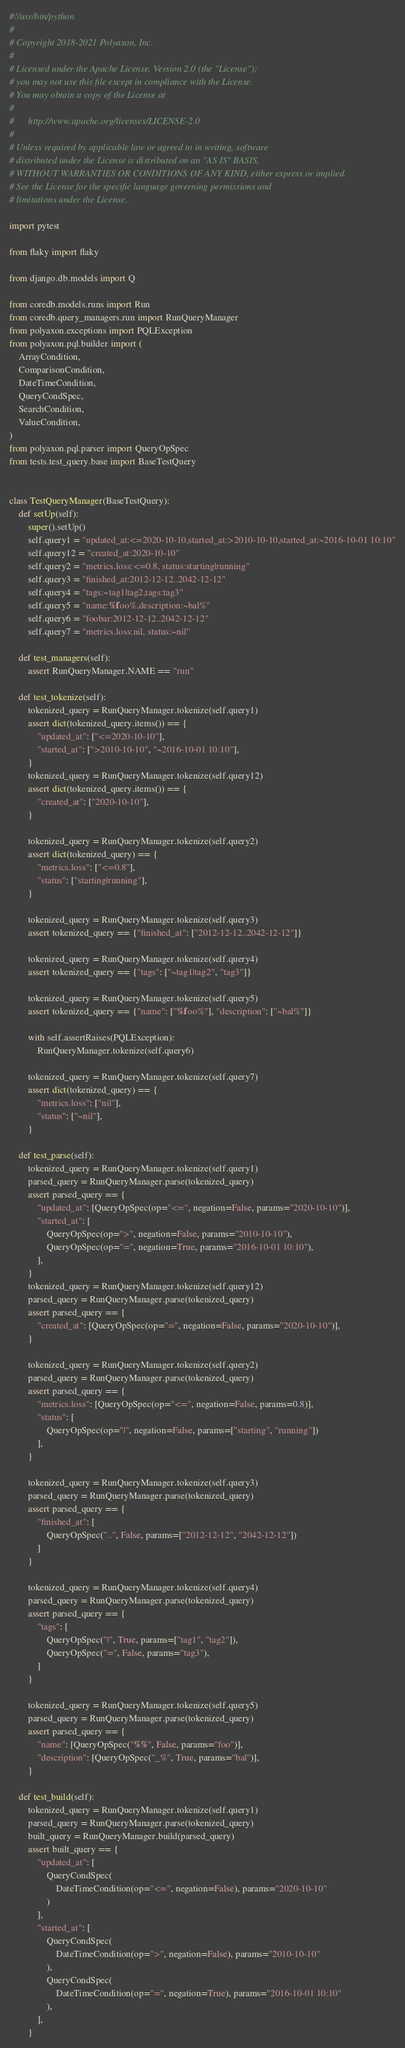Convert code to text. <code><loc_0><loc_0><loc_500><loc_500><_Python_>#!/usr/bin/python
#
# Copyright 2018-2021 Polyaxon, Inc.
#
# Licensed under the Apache License, Version 2.0 (the "License");
# you may not use this file except in compliance with the License.
# You may obtain a copy of the License at
#
#      http://www.apache.org/licenses/LICENSE-2.0
#
# Unless required by applicable law or agreed to in writing, software
# distributed under the License is distributed on an "AS IS" BASIS,
# WITHOUT WARRANTIES OR CONDITIONS OF ANY KIND, either express or implied.
# See the License for the specific language governing permissions and
# limitations under the License.

import pytest

from flaky import flaky

from django.db.models import Q

from coredb.models.runs import Run
from coredb.query_managers.run import RunQueryManager
from polyaxon.exceptions import PQLException
from polyaxon.pql.builder import (
    ArrayCondition,
    ComparisonCondition,
    DateTimeCondition,
    QueryCondSpec,
    SearchCondition,
    ValueCondition,
)
from polyaxon.pql.parser import QueryOpSpec
from tests.test_query.base import BaseTestQuery


class TestQueryManager(BaseTestQuery):
    def setUp(self):
        super().setUp()
        self.query1 = "updated_at:<=2020-10-10,started_at:>2010-10-10,started_at:~2016-10-01 10:10"
        self.query12 = "created_at:2020-10-10"
        self.query2 = "metrics.loss:<=0.8, status:starting|running"
        self.query3 = "finished_at:2012-12-12..2042-12-12"
        self.query4 = "tags:~tag1|tag2,tags:tag3"
        self.query5 = "name:%foo%,description:~bal%"
        self.query6 = "foobar:2012-12-12..2042-12-12"
        self.query7 = "metrics.loss:nil, status:~nil"

    def test_managers(self):
        assert RunQueryManager.NAME == "run"

    def test_tokenize(self):
        tokenized_query = RunQueryManager.tokenize(self.query1)
        assert dict(tokenized_query.items()) == {
            "updated_at": ["<=2020-10-10"],
            "started_at": [">2010-10-10", "~2016-10-01 10:10"],
        }
        tokenized_query = RunQueryManager.tokenize(self.query12)
        assert dict(tokenized_query.items()) == {
            "created_at": ["2020-10-10"],
        }

        tokenized_query = RunQueryManager.tokenize(self.query2)
        assert dict(tokenized_query) == {
            "metrics.loss": ["<=0.8"],
            "status": ["starting|running"],
        }

        tokenized_query = RunQueryManager.tokenize(self.query3)
        assert tokenized_query == {"finished_at": ["2012-12-12..2042-12-12"]}

        tokenized_query = RunQueryManager.tokenize(self.query4)
        assert tokenized_query == {"tags": ["~tag1|tag2", "tag3"]}

        tokenized_query = RunQueryManager.tokenize(self.query5)
        assert tokenized_query == {"name": ["%foo%"], "description": ["~bal%"]}

        with self.assertRaises(PQLException):
            RunQueryManager.tokenize(self.query6)

        tokenized_query = RunQueryManager.tokenize(self.query7)
        assert dict(tokenized_query) == {
            "metrics.loss": ["nil"],
            "status": ["~nil"],
        }

    def test_parse(self):
        tokenized_query = RunQueryManager.tokenize(self.query1)
        parsed_query = RunQueryManager.parse(tokenized_query)
        assert parsed_query == {
            "updated_at": [QueryOpSpec(op="<=", negation=False, params="2020-10-10")],
            "started_at": [
                QueryOpSpec(op=">", negation=False, params="2010-10-10"),
                QueryOpSpec(op="=", negation=True, params="2016-10-01 10:10"),
            ],
        }
        tokenized_query = RunQueryManager.tokenize(self.query12)
        parsed_query = RunQueryManager.parse(tokenized_query)
        assert parsed_query == {
            "created_at": [QueryOpSpec(op="=", negation=False, params="2020-10-10")],
        }

        tokenized_query = RunQueryManager.tokenize(self.query2)
        parsed_query = RunQueryManager.parse(tokenized_query)
        assert parsed_query == {
            "metrics.loss": [QueryOpSpec(op="<=", negation=False, params=0.8)],
            "status": [
                QueryOpSpec(op="|", negation=False, params=["starting", "running"])
            ],
        }

        tokenized_query = RunQueryManager.tokenize(self.query3)
        parsed_query = RunQueryManager.parse(tokenized_query)
        assert parsed_query == {
            "finished_at": [
                QueryOpSpec("..", False, params=["2012-12-12", "2042-12-12"])
            ]
        }

        tokenized_query = RunQueryManager.tokenize(self.query4)
        parsed_query = RunQueryManager.parse(tokenized_query)
        assert parsed_query == {
            "tags": [
                QueryOpSpec("|", True, params=["tag1", "tag2"]),
                QueryOpSpec("=", False, params="tag3"),
            ]
        }

        tokenized_query = RunQueryManager.tokenize(self.query5)
        parsed_query = RunQueryManager.parse(tokenized_query)
        assert parsed_query == {
            "name": [QueryOpSpec("%%", False, params="foo")],
            "description": [QueryOpSpec("_%", True, params="bal")],
        }

    def test_build(self):
        tokenized_query = RunQueryManager.tokenize(self.query1)
        parsed_query = RunQueryManager.parse(tokenized_query)
        built_query = RunQueryManager.build(parsed_query)
        assert built_query == {
            "updated_at": [
                QueryCondSpec(
                    DateTimeCondition(op="<=", negation=False), params="2020-10-10"
                )
            ],
            "started_at": [
                QueryCondSpec(
                    DateTimeCondition(op=">", negation=False), params="2010-10-10"
                ),
                QueryCondSpec(
                    DateTimeCondition(op="=", negation=True), params="2016-10-01 10:10"
                ),
            ],
        }
</code> 